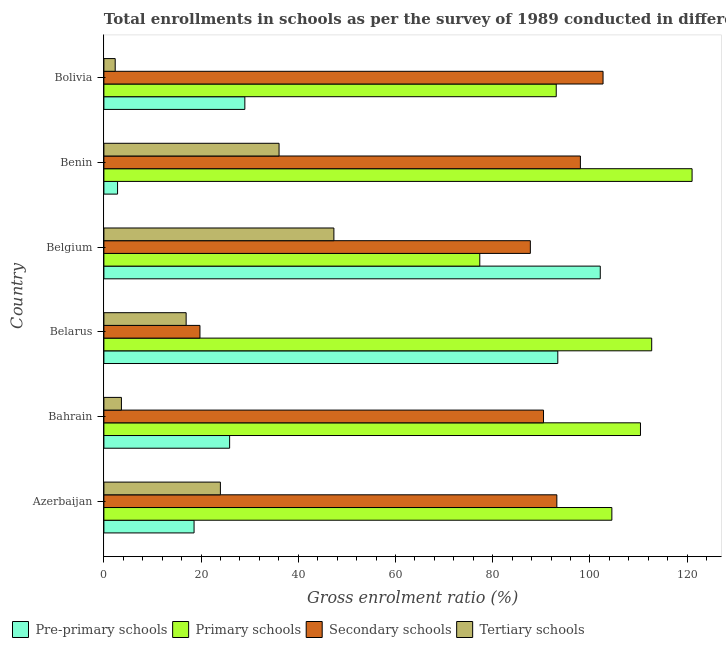How many groups of bars are there?
Your answer should be compact. 6. How many bars are there on the 6th tick from the top?
Your answer should be compact. 4. How many bars are there on the 3rd tick from the bottom?
Offer a terse response. 4. What is the label of the 4th group of bars from the top?
Provide a succinct answer. Belarus. What is the gross enrolment ratio in secondary schools in Bolivia?
Offer a very short reply. 102.7. Across all countries, what is the maximum gross enrolment ratio in pre-primary schools?
Offer a terse response. 102.13. Across all countries, what is the minimum gross enrolment ratio in tertiary schools?
Offer a very short reply. 2.33. In which country was the gross enrolment ratio in primary schools maximum?
Ensure brevity in your answer.  Benin. In which country was the gross enrolment ratio in pre-primary schools minimum?
Provide a succinct answer. Benin. What is the total gross enrolment ratio in secondary schools in the graph?
Provide a short and direct response. 491.91. What is the difference between the gross enrolment ratio in pre-primary schools in Belgium and that in Bolivia?
Offer a very short reply. 73.13. What is the difference between the gross enrolment ratio in pre-primary schools in Azerbaijan and the gross enrolment ratio in tertiary schools in Bolivia?
Provide a succinct answer. 16.22. What is the average gross enrolment ratio in tertiary schools per country?
Provide a succinct answer. 21.7. What is the difference between the gross enrolment ratio in primary schools and gross enrolment ratio in tertiary schools in Belgium?
Offer a terse response. 30.02. What is the ratio of the gross enrolment ratio in tertiary schools in Bahrain to that in Belarus?
Keep it short and to the point. 0.21. Is the gross enrolment ratio in tertiary schools in Bahrain less than that in Bolivia?
Provide a short and direct response. No. What is the difference between the highest and the second highest gross enrolment ratio in secondary schools?
Your response must be concise. 4.66. What is the difference between the highest and the lowest gross enrolment ratio in primary schools?
Give a very brief answer. 43.68. In how many countries, is the gross enrolment ratio in primary schools greater than the average gross enrolment ratio in primary schools taken over all countries?
Offer a very short reply. 4. Is the sum of the gross enrolment ratio in pre-primary schools in Belarus and Bolivia greater than the maximum gross enrolment ratio in primary schools across all countries?
Make the answer very short. Yes. Is it the case that in every country, the sum of the gross enrolment ratio in pre-primary schools and gross enrolment ratio in secondary schools is greater than the sum of gross enrolment ratio in tertiary schools and gross enrolment ratio in primary schools?
Keep it short and to the point. No. What does the 2nd bar from the top in Bolivia represents?
Offer a very short reply. Secondary schools. What does the 4th bar from the bottom in Bahrain represents?
Your answer should be compact. Tertiary schools. Is it the case that in every country, the sum of the gross enrolment ratio in pre-primary schools and gross enrolment ratio in primary schools is greater than the gross enrolment ratio in secondary schools?
Offer a very short reply. Yes. How many bars are there?
Ensure brevity in your answer.  24. How many countries are there in the graph?
Offer a very short reply. 6. Are the values on the major ticks of X-axis written in scientific E-notation?
Your response must be concise. No. Does the graph contain any zero values?
Make the answer very short. No. Does the graph contain grids?
Make the answer very short. No. How are the legend labels stacked?
Ensure brevity in your answer.  Horizontal. What is the title of the graph?
Keep it short and to the point. Total enrollments in schools as per the survey of 1989 conducted in different countries. What is the Gross enrolment ratio (%) of Pre-primary schools in Azerbaijan?
Provide a succinct answer. 18.55. What is the Gross enrolment ratio (%) of Primary schools in Azerbaijan?
Ensure brevity in your answer.  104.52. What is the Gross enrolment ratio (%) of Secondary schools in Azerbaijan?
Provide a short and direct response. 93.2. What is the Gross enrolment ratio (%) of Tertiary schools in Azerbaijan?
Your answer should be compact. 23.97. What is the Gross enrolment ratio (%) of Pre-primary schools in Bahrain?
Your response must be concise. 25.87. What is the Gross enrolment ratio (%) of Primary schools in Bahrain?
Ensure brevity in your answer.  110.4. What is the Gross enrolment ratio (%) of Secondary schools in Bahrain?
Provide a short and direct response. 90.46. What is the Gross enrolment ratio (%) in Tertiary schools in Bahrain?
Your answer should be compact. 3.61. What is the Gross enrolment ratio (%) in Pre-primary schools in Belarus?
Keep it short and to the point. 93.39. What is the Gross enrolment ratio (%) of Primary schools in Belarus?
Offer a very short reply. 112.71. What is the Gross enrolment ratio (%) of Secondary schools in Belarus?
Keep it short and to the point. 19.76. What is the Gross enrolment ratio (%) in Tertiary schools in Belarus?
Give a very brief answer. 16.92. What is the Gross enrolment ratio (%) of Pre-primary schools in Belgium?
Keep it short and to the point. 102.13. What is the Gross enrolment ratio (%) of Primary schools in Belgium?
Provide a short and direct response. 77.34. What is the Gross enrolment ratio (%) in Secondary schools in Belgium?
Offer a terse response. 87.74. What is the Gross enrolment ratio (%) in Tertiary schools in Belgium?
Offer a terse response. 47.32. What is the Gross enrolment ratio (%) of Pre-primary schools in Benin?
Offer a terse response. 2.81. What is the Gross enrolment ratio (%) in Primary schools in Benin?
Provide a short and direct response. 121.02. What is the Gross enrolment ratio (%) of Secondary schools in Benin?
Give a very brief answer. 98.04. What is the Gross enrolment ratio (%) in Tertiary schools in Benin?
Your response must be concise. 36.04. What is the Gross enrolment ratio (%) in Pre-primary schools in Bolivia?
Your answer should be very brief. 29. What is the Gross enrolment ratio (%) in Primary schools in Bolivia?
Your response must be concise. 93.07. What is the Gross enrolment ratio (%) of Secondary schools in Bolivia?
Make the answer very short. 102.7. What is the Gross enrolment ratio (%) in Tertiary schools in Bolivia?
Provide a succinct answer. 2.33. Across all countries, what is the maximum Gross enrolment ratio (%) in Pre-primary schools?
Offer a very short reply. 102.13. Across all countries, what is the maximum Gross enrolment ratio (%) in Primary schools?
Your answer should be compact. 121.02. Across all countries, what is the maximum Gross enrolment ratio (%) of Secondary schools?
Ensure brevity in your answer.  102.7. Across all countries, what is the maximum Gross enrolment ratio (%) of Tertiary schools?
Your answer should be compact. 47.32. Across all countries, what is the minimum Gross enrolment ratio (%) of Pre-primary schools?
Provide a short and direct response. 2.81. Across all countries, what is the minimum Gross enrolment ratio (%) of Primary schools?
Offer a very short reply. 77.34. Across all countries, what is the minimum Gross enrolment ratio (%) of Secondary schools?
Give a very brief answer. 19.76. Across all countries, what is the minimum Gross enrolment ratio (%) in Tertiary schools?
Ensure brevity in your answer.  2.33. What is the total Gross enrolment ratio (%) of Pre-primary schools in the graph?
Make the answer very short. 271.76. What is the total Gross enrolment ratio (%) in Primary schools in the graph?
Your answer should be compact. 619.07. What is the total Gross enrolment ratio (%) of Secondary schools in the graph?
Provide a short and direct response. 491.91. What is the total Gross enrolment ratio (%) in Tertiary schools in the graph?
Offer a terse response. 130.19. What is the difference between the Gross enrolment ratio (%) of Pre-primary schools in Azerbaijan and that in Bahrain?
Provide a short and direct response. -7.32. What is the difference between the Gross enrolment ratio (%) in Primary schools in Azerbaijan and that in Bahrain?
Offer a terse response. -5.89. What is the difference between the Gross enrolment ratio (%) in Secondary schools in Azerbaijan and that in Bahrain?
Keep it short and to the point. 2.74. What is the difference between the Gross enrolment ratio (%) of Tertiary schools in Azerbaijan and that in Bahrain?
Keep it short and to the point. 20.37. What is the difference between the Gross enrolment ratio (%) in Pre-primary schools in Azerbaijan and that in Belarus?
Make the answer very short. -74.84. What is the difference between the Gross enrolment ratio (%) of Primary schools in Azerbaijan and that in Belarus?
Your answer should be compact. -8.2. What is the difference between the Gross enrolment ratio (%) of Secondary schools in Azerbaijan and that in Belarus?
Offer a very short reply. 73.43. What is the difference between the Gross enrolment ratio (%) in Tertiary schools in Azerbaijan and that in Belarus?
Provide a succinct answer. 7.05. What is the difference between the Gross enrolment ratio (%) in Pre-primary schools in Azerbaijan and that in Belgium?
Your response must be concise. -83.58. What is the difference between the Gross enrolment ratio (%) in Primary schools in Azerbaijan and that in Belgium?
Provide a short and direct response. 27.18. What is the difference between the Gross enrolment ratio (%) in Secondary schools in Azerbaijan and that in Belgium?
Keep it short and to the point. 5.45. What is the difference between the Gross enrolment ratio (%) in Tertiary schools in Azerbaijan and that in Belgium?
Give a very brief answer. -23.35. What is the difference between the Gross enrolment ratio (%) of Pre-primary schools in Azerbaijan and that in Benin?
Make the answer very short. 15.74. What is the difference between the Gross enrolment ratio (%) in Primary schools in Azerbaijan and that in Benin?
Your answer should be compact. -16.51. What is the difference between the Gross enrolment ratio (%) of Secondary schools in Azerbaijan and that in Benin?
Give a very brief answer. -4.84. What is the difference between the Gross enrolment ratio (%) of Tertiary schools in Azerbaijan and that in Benin?
Your answer should be compact. -12.07. What is the difference between the Gross enrolment ratio (%) of Pre-primary schools in Azerbaijan and that in Bolivia?
Your answer should be very brief. -10.45. What is the difference between the Gross enrolment ratio (%) of Primary schools in Azerbaijan and that in Bolivia?
Offer a very short reply. 11.45. What is the difference between the Gross enrolment ratio (%) in Secondary schools in Azerbaijan and that in Bolivia?
Keep it short and to the point. -9.51. What is the difference between the Gross enrolment ratio (%) of Tertiary schools in Azerbaijan and that in Bolivia?
Give a very brief answer. 21.64. What is the difference between the Gross enrolment ratio (%) in Pre-primary schools in Bahrain and that in Belarus?
Your answer should be very brief. -67.52. What is the difference between the Gross enrolment ratio (%) of Primary schools in Bahrain and that in Belarus?
Ensure brevity in your answer.  -2.31. What is the difference between the Gross enrolment ratio (%) of Secondary schools in Bahrain and that in Belarus?
Provide a succinct answer. 70.69. What is the difference between the Gross enrolment ratio (%) in Tertiary schools in Bahrain and that in Belarus?
Ensure brevity in your answer.  -13.32. What is the difference between the Gross enrolment ratio (%) of Pre-primary schools in Bahrain and that in Belgium?
Provide a short and direct response. -76.26. What is the difference between the Gross enrolment ratio (%) of Primary schools in Bahrain and that in Belgium?
Keep it short and to the point. 33.06. What is the difference between the Gross enrolment ratio (%) in Secondary schools in Bahrain and that in Belgium?
Your answer should be compact. 2.71. What is the difference between the Gross enrolment ratio (%) of Tertiary schools in Bahrain and that in Belgium?
Your answer should be compact. -43.72. What is the difference between the Gross enrolment ratio (%) of Pre-primary schools in Bahrain and that in Benin?
Make the answer very short. 23.06. What is the difference between the Gross enrolment ratio (%) in Primary schools in Bahrain and that in Benin?
Keep it short and to the point. -10.62. What is the difference between the Gross enrolment ratio (%) in Secondary schools in Bahrain and that in Benin?
Ensure brevity in your answer.  -7.58. What is the difference between the Gross enrolment ratio (%) of Tertiary schools in Bahrain and that in Benin?
Offer a terse response. -32.44. What is the difference between the Gross enrolment ratio (%) in Pre-primary schools in Bahrain and that in Bolivia?
Your response must be concise. -3.13. What is the difference between the Gross enrolment ratio (%) in Primary schools in Bahrain and that in Bolivia?
Offer a terse response. 17.33. What is the difference between the Gross enrolment ratio (%) in Secondary schools in Bahrain and that in Bolivia?
Your answer should be very brief. -12.25. What is the difference between the Gross enrolment ratio (%) in Tertiary schools in Bahrain and that in Bolivia?
Make the answer very short. 1.28. What is the difference between the Gross enrolment ratio (%) in Pre-primary schools in Belarus and that in Belgium?
Keep it short and to the point. -8.74. What is the difference between the Gross enrolment ratio (%) in Primary schools in Belarus and that in Belgium?
Give a very brief answer. 35.37. What is the difference between the Gross enrolment ratio (%) in Secondary schools in Belarus and that in Belgium?
Give a very brief answer. -67.98. What is the difference between the Gross enrolment ratio (%) in Tertiary schools in Belarus and that in Belgium?
Your response must be concise. -30.4. What is the difference between the Gross enrolment ratio (%) of Pre-primary schools in Belarus and that in Benin?
Give a very brief answer. 90.58. What is the difference between the Gross enrolment ratio (%) of Primary schools in Belarus and that in Benin?
Offer a terse response. -8.31. What is the difference between the Gross enrolment ratio (%) in Secondary schools in Belarus and that in Benin?
Your answer should be compact. -78.28. What is the difference between the Gross enrolment ratio (%) of Tertiary schools in Belarus and that in Benin?
Your answer should be compact. -19.12. What is the difference between the Gross enrolment ratio (%) of Pre-primary schools in Belarus and that in Bolivia?
Provide a succinct answer. 64.39. What is the difference between the Gross enrolment ratio (%) of Primary schools in Belarus and that in Bolivia?
Your response must be concise. 19.64. What is the difference between the Gross enrolment ratio (%) of Secondary schools in Belarus and that in Bolivia?
Make the answer very short. -82.94. What is the difference between the Gross enrolment ratio (%) in Tertiary schools in Belarus and that in Bolivia?
Ensure brevity in your answer.  14.59. What is the difference between the Gross enrolment ratio (%) in Pre-primary schools in Belgium and that in Benin?
Your response must be concise. 99.32. What is the difference between the Gross enrolment ratio (%) of Primary schools in Belgium and that in Benin?
Offer a terse response. -43.68. What is the difference between the Gross enrolment ratio (%) of Secondary schools in Belgium and that in Benin?
Offer a terse response. -10.3. What is the difference between the Gross enrolment ratio (%) in Tertiary schools in Belgium and that in Benin?
Provide a succinct answer. 11.28. What is the difference between the Gross enrolment ratio (%) in Pre-primary schools in Belgium and that in Bolivia?
Make the answer very short. 73.13. What is the difference between the Gross enrolment ratio (%) of Primary schools in Belgium and that in Bolivia?
Make the answer very short. -15.73. What is the difference between the Gross enrolment ratio (%) of Secondary schools in Belgium and that in Bolivia?
Your answer should be very brief. -14.96. What is the difference between the Gross enrolment ratio (%) in Tertiary schools in Belgium and that in Bolivia?
Ensure brevity in your answer.  45. What is the difference between the Gross enrolment ratio (%) in Pre-primary schools in Benin and that in Bolivia?
Your answer should be compact. -26.19. What is the difference between the Gross enrolment ratio (%) of Primary schools in Benin and that in Bolivia?
Provide a short and direct response. 27.95. What is the difference between the Gross enrolment ratio (%) in Secondary schools in Benin and that in Bolivia?
Your answer should be very brief. -4.66. What is the difference between the Gross enrolment ratio (%) of Tertiary schools in Benin and that in Bolivia?
Give a very brief answer. 33.71. What is the difference between the Gross enrolment ratio (%) in Pre-primary schools in Azerbaijan and the Gross enrolment ratio (%) in Primary schools in Bahrain?
Make the answer very short. -91.85. What is the difference between the Gross enrolment ratio (%) in Pre-primary schools in Azerbaijan and the Gross enrolment ratio (%) in Secondary schools in Bahrain?
Give a very brief answer. -71.9. What is the difference between the Gross enrolment ratio (%) of Pre-primary schools in Azerbaijan and the Gross enrolment ratio (%) of Tertiary schools in Bahrain?
Your response must be concise. 14.95. What is the difference between the Gross enrolment ratio (%) in Primary schools in Azerbaijan and the Gross enrolment ratio (%) in Secondary schools in Bahrain?
Your answer should be very brief. 14.06. What is the difference between the Gross enrolment ratio (%) of Primary schools in Azerbaijan and the Gross enrolment ratio (%) of Tertiary schools in Bahrain?
Ensure brevity in your answer.  100.91. What is the difference between the Gross enrolment ratio (%) of Secondary schools in Azerbaijan and the Gross enrolment ratio (%) of Tertiary schools in Bahrain?
Your response must be concise. 89.59. What is the difference between the Gross enrolment ratio (%) of Pre-primary schools in Azerbaijan and the Gross enrolment ratio (%) of Primary schools in Belarus?
Offer a terse response. -94.16. What is the difference between the Gross enrolment ratio (%) in Pre-primary schools in Azerbaijan and the Gross enrolment ratio (%) in Secondary schools in Belarus?
Provide a short and direct response. -1.21. What is the difference between the Gross enrolment ratio (%) in Pre-primary schools in Azerbaijan and the Gross enrolment ratio (%) in Tertiary schools in Belarus?
Provide a short and direct response. 1.63. What is the difference between the Gross enrolment ratio (%) in Primary schools in Azerbaijan and the Gross enrolment ratio (%) in Secondary schools in Belarus?
Offer a very short reply. 84.75. What is the difference between the Gross enrolment ratio (%) of Primary schools in Azerbaijan and the Gross enrolment ratio (%) of Tertiary schools in Belarus?
Your answer should be compact. 87.6. What is the difference between the Gross enrolment ratio (%) in Secondary schools in Azerbaijan and the Gross enrolment ratio (%) in Tertiary schools in Belarus?
Give a very brief answer. 76.28. What is the difference between the Gross enrolment ratio (%) of Pre-primary schools in Azerbaijan and the Gross enrolment ratio (%) of Primary schools in Belgium?
Your response must be concise. -58.79. What is the difference between the Gross enrolment ratio (%) of Pre-primary schools in Azerbaijan and the Gross enrolment ratio (%) of Secondary schools in Belgium?
Offer a terse response. -69.19. What is the difference between the Gross enrolment ratio (%) in Pre-primary schools in Azerbaijan and the Gross enrolment ratio (%) in Tertiary schools in Belgium?
Offer a very short reply. -28.77. What is the difference between the Gross enrolment ratio (%) of Primary schools in Azerbaijan and the Gross enrolment ratio (%) of Secondary schools in Belgium?
Provide a short and direct response. 16.77. What is the difference between the Gross enrolment ratio (%) of Primary schools in Azerbaijan and the Gross enrolment ratio (%) of Tertiary schools in Belgium?
Make the answer very short. 57.19. What is the difference between the Gross enrolment ratio (%) of Secondary schools in Azerbaijan and the Gross enrolment ratio (%) of Tertiary schools in Belgium?
Your answer should be very brief. 45.87. What is the difference between the Gross enrolment ratio (%) in Pre-primary schools in Azerbaijan and the Gross enrolment ratio (%) in Primary schools in Benin?
Offer a terse response. -102.47. What is the difference between the Gross enrolment ratio (%) of Pre-primary schools in Azerbaijan and the Gross enrolment ratio (%) of Secondary schools in Benin?
Offer a terse response. -79.49. What is the difference between the Gross enrolment ratio (%) in Pre-primary schools in Azerbaijan and the Gross enrolment ratio (%) in Tertiary schools in Benin?
Keep it short and to the point. -17.49. What is the difference between the Gross enrolment ratio (%) of Primary schools in Azerbaijan and the Gross enrolment ratio (%) of Secondary schools in Benin?
Your answer should be very brief. 6.48. What is the difference between the Gross enrolment ratio (%) in Primary schools in Azerbaijan and the Gross enrolment ratio (%) in Tertiary schools in Benin?
Keep it short and to the point. 68.48. What is the difference between the Gross enrolment ratio (%) of Secondary schools in Azerbaijan and the Gross enrolment ratio (%) of Tertiary schools in Benin?
Provide a short and direct response. 57.16. What is the difference between the Gross enrolment ratio (%) in Pre-primary schools in Azerbaijan and the Gross enrolment ratio (%) in Primary schools in Bolivia?
Your answer should be compact. -74.52. What is the difference between the Gross enrolment ratio (%) of Pre-primary schools in Azerbaijan and the Gross enrolment ratio (%) of Secondary schools in Bolivia?
Offer a terse response. -84.15. What is the difference between the Gross enrolment ratio (%) in Pre-primary schools in Azerbaijan and the Gross enrolment ratio (%) in Tertiary schools in Bolivia?
Your answer should be compact. 16.22. What is the difference between the Gross enrolment ratio (%) of Primary schools in Azerbaijan and the Gross enrolment ratio (%) of Secondary schools in Bolivia?
Offer a very short reply. 1.81. What is the difference between the Gross enrolment ratio (%) in Primary schools in Azerbaijan and the Gross enrolment ratio (%) in Tertiary schools in Bolivia?
Give a very brief answer. 102.19. What is the difference between the Gross enrolment ratio (%) of Secondary schools in Azerbaijan and the Gross enrolment ratio (%) of Tertiary schools in Bolivia?
Ensure brevity in your answer.  90.87. What is the difference between the Gross enrolment ratio (%) in Pre-primary schools in Bahrain and the Gross enrolment ratio (%) in Primary schools in Belarus?
Your answer should be very brief. -86.84. What is the difference between the Gross enrolment ratio (%) in Pre-primary schools in Bahrain and the Gross enrolment ratio (%) in Secondary schools in Belarus?
Give a very brief answer. 6.11. What is the difference between the Gross enrolment ratio (%) in Pre-primary schools in Bahrain and the Gross enrolment ratio (%) in Tertiary schools in Belarus?
Give a very brief answer. 8.95. What is the difference between the Gross enrolment ratio (%) in Primary schools in Bahrain and the Gross enrolment ratio (%) in Secondary schools in Belarus?
Make the answer very short. 90.64. What is the difference between the Gross enrolment ratio (%) of Primary schools in Bahrain and the Gross enrolment ratio (%) of Tertiary schools in Belarus?
Give a very brief answer. 93.48. What is the difference between the Gross enrolment ratio (%) of Secondary schools in Bahrain and the Gross enrolment ratio (%) of Tertiary schools in Belarus?
Provide a short and direct response. 73.53. What is the difference between the Gross enrolment ratio (%) of Pre-primary schools in Bahrain and the Gross enrolment ratio (%) of Primary schools in Belgium?
Your answer should be very brief. -51.47. What is the difference between the Gross enrolment ratio (%) in Pre-primary schools in Bahrain and the Gross enrolment ratio (%) in Secondary schools in Belgium?
Offer a very short reply. -61.87. What is the difference between the Gross enrolment ratio (%) of Pre-primary schools in Bahrain and the Gross enrolment ratio (%) of Tertiary schools in Belgium?
Provide a succinct answer. -21.45. What is the difference between the Gross enrolment ratio (%) of Primary schools in Bahrain and the Gross enrolment ratio (%) of Secondary schools in Belgium?
Keep it short and to the point. 22.66. What is the difference between the Gross enrolment ratio (%) of Primary schools in Bahrain and the Gross enrolment ratio (%) of Tertiary schools in Belgium?
Offer a terse response. 63.08. What is the difference between the Gross enrolment ratio (%) of Secondary schools in Bahrain and the Gross enrolment ratio (%) of Tertiary schools in Belgium?
Your response must be concise. 43.13. What is the difference between the Gross enrolment ratio (%) in Pre-primary schools in Bahrain and the Gross enrolment ratio (%) in Primary schools in Benin?
Provide a succinct answer. -95.15. What is the difference between the Gross enrolment ratio (%) of Pre-primary schools in Bahrain and the Gross enrolment ratio (%) of Secondary schools in Benin?
Provide a short and direct response. -72.17. What is the difference between the Gross enrolment ratio (%) of Pre-primary schools in Bahrain and the Gross enrolment ratio (%) of Tertiary schools in Benin?
Ensure brevity in your answer.  -10.17. What is the difference between the Gross enrolment ratio (%) in Primary schools in Bahrain and the Gross enrolment ratio (%) in Secondary schools in Benin?
Your answer should be compact. 12.36. What is the difference between the Gross enrolment ratio (%) of Primary schools in Bahrain and the Gross enrolment ratio (%) of Tertiary schools in Benin?
Provide a short and direct response. 74.36. What is the difference between the Gross enrolment ratio (%) of Secondary schools in Bahrain and the Gross enrolment ratio (%) of Tertiary schools in Benin?
Your response must be concise. 54.41. What is the difference between the Gross enrolment ratio (%) of Pre-primary schools in Bahrain and the Gross enrolment ratio (%) of Primary schools in Bolivia?
Offer a very short reply. -67.2. What is the difference between the Gross enrolment ratio (%) in Pre-primary schools in Bahrain and the Gross enrolment ratio (%) in Secondary schools in Bolivia?
Offer a terse response. -76.83. What is the difference between the Gross enrolment ratio (%) of Pre-primary schools in Bahrain and the Gross enrolment ratio (%) of Tertiary schools in Bolivia?
Provide a short and direct response. 23.54. What is the difference between the Gross enrolment ratio (%) of Primary schools in Bahrain and the Gross enrolment ratio (%) of Secondary schools in Bolivia?
Offer a very short reply. 7.7. What is the difference between the Gross enrolment ratio (%) of Primary schools in Bahrain and the Gross enrolment ratio (%) of Tertiary schools in Bolivia?
Make the answer very short. 108.07. What is the difference between the Gross enrolment ratio (%) of Secondary schools in Bahrain and the Gross enrolment ratio (%) of Tertiary schools in Bolivia?
Offer a terse response. 88.13. What is the difference between the Gross enrolment ratio (%) in Pre-primary schools in Belarus and the Gross enrolment ratio (%) in Primary schools in Belgium?
Your answer should be very brief. 16.05. What is the difference between the Gross enrolment ratio (%) of Pre-primary schools in Belarus and the Gross enrolment ratio (%) of Secondary schools in Belgium?
Offer a terse response. 5.65. What is the difference between the Gross enrolment ratio (%) of Pre-primary schools in Belarus and the Gross enrolment ratio (%) of Tertiary schools in Belgium?
Give a very brief answer. 46.07. What is the difference between the Gross enrolment ratio (%) in Primary schools in Belarus and the Gross enrolment ratio (%) in Secondary schools in Belgium?
Offer a terse response. 24.97. What is the difference between the Gross enrolment ratio (%) in Primary schools in Belarus and the Gross enrolment ratio (%) in Tertiary schools in Belgium?
Offer a terse response. 65.39. What is the difference between the Gross enrolment ratio (%) of Secondary schools in Belarus and the Gross enrolment ratio (%) of Tertiary schools in Belgium?
Give a very brief answer. -27.56. What is the difference between the Gross enrolment ratio (%) in Pre-primary schools in Belarus and the Gross enrolment ratio (%) in Primary schools in Benin?
Keep it short and to the point. -27.63. What is the difference between the Gross enrolment ratio (%) of Pre-primary schools in Belarus and the Gross enrolment ratio (%) of Secondary schools in Benin?
Provide a short and direct response. -4.65. What is the difference between the Gross enrolment ratio (%) of Pre-primary schools in Belarus and the Gross enrolment ratio (%) of Tertiary schools in Benin?
Your response must be concise. 57.35. What is the difference between the Gross enrolment ratio (%) in Primary schools in Belarus and the Gross enrolment ratio (%) in Secondary schools in Benin?
Provide a succinct answer. 14.67. What is the difference between the Gross enrolment ratio (%) in Primary schools in Belarus and the Gross enrolment ratio (%) in Tertiary schools in Benin?
Provide a short and direct response. 76.67. What is the difference between the Gross enrolment ratio (%) in Secondary schools in Belarus and the Gross enrolment ratio (%) in Tertiary schools in Benin?
Keep it short and to the point. -16.28. What is the difference between the Gross enrolment ratio (%) in Pre-primary schools in Belarus and the Gross enrolment ratio (%) in Primary schools in Bolivia?
Ensure brevity in your answer.  0.32. What is the difference between the Gross enrolment ratio (%) of Pre-primary schools in Belarus and the Gross enrolment ratio (%) of Secondary schools in Bolivia?
Your answer should be compact. -9.31. What is the difference between the Gross enrolment ratio (%) in Pre-primary schools in Belarus and the Gross enrolment ratio (%) in Tertiary schools in Bolivia?
Your response must be concise. 91.07. What is the difference between the Gross enrolment ratio (%) in Primary schools in Belarus and the Gross enrolment ratio (%) in Secondary schools in Bolivia?
Provide a succinct answer. 10.01. What is the difference between the Gross enrolment ratio (%) in Primary schools in Belarus and the Gross enrolment ratio (%) in Tertiary schools in Bolivia?
Make the answer very short. 110.39. What is the difference between the Gross enrolment ratio (%) in Secondary schools in Belarus and the Gross enrolment ratio (%) in Tertiary schools in Bolivia?
Make the answer very short. 17.44. What is the difference between the Gross enrolment ratio (%) in Pre-primary schools in Belgium and the Gross enrolment ratio (%) in Primary schools in Benin?
Offer a terse response. -18.89. What is the difference between the Gross enrolment ratio (%) in Pre-primary schools in Belgium and the Gross enrolment ratio (%) in Secondary schools in Benin?
Your response must be concise. 4.09. What is the difference between the Gross enrolment ratio (%) of Pre-primary schools in Belgium and the Gross enrolment ratio (%) of Tertiary schools in Benin?
Your response must be concise. 66.09. What is the difference between the Gross enrolment ratio (%) in Primary schools in Belgium and the Gross enrolment ratio (%) in Secondary schools in Benin?
Offer a very short reply. -20.7. What is the difference between the Gross enrolment ratio (%) of Primary schools in Belgium and the Gross enrolment ratio (%) of Tertiary schools in Benin?
Your answer should be compact. 41.3. What is the difference between the Gross enrolment ratio (%) in Secondary schools in Belgium and the Gross enrolment ratio (%) in Tertiary schools in Benin?
Give a very brief answer. 51.7. What is the difference between the Gross enrolment ratio (%) of Pre-primary schools in Belgium and the Gross enrolment ratio (%) of Primary schools in Bolivia?
Provide a short and direct response. 9.06. What is the difference between the Gross enrolment ratio (%) of Pre-primary schools in Belgium and the Gross enrolment ratio (%) of Secondary schools in Bolivia?
Your response must be concise. -0.57. What is the difference between the Gross enrolment ratio (%) in Pre-primary schools in Belgium and the Gross enrolment ratio (%) in Tertiary schools in Bolivia?
Provide a succinct answer. 99.8. What is the difference between the Gross enrolment ratio (%) in Primary schools in Belgium and the Gross enrolment ratio (%) in Secondary schools in Bolivia?
Provide a short and direct response. -25.36. What is the difference between the Gross enrolment ratio (%) of Primary schools in Belgium and the Gross enrolment ratio (%) of Tertiary schools in Bolivia?
Your answer should be very brief. 75.01. What is the difference between the Gross enrolment ratio (%) in Secondary schools in Belgium and the Gross enrolment ratio (%) in Tertiary schools in Bolivia?
Your answer should be compact. 85.42. What is the difference between the Gross enrolment ratio (%) of Pre-primary schools in Benin and the Gross enrolment ratio (%) of Primary schools in Bolivia?
Provide a succinct answer. -90.26. What is the difference between the Gross enrolment ratio (%) of Pre-primary schools in Benin and the Gross enrolment ratio (%) of Secondary schools in Bolivia?
Offer a very short reply. -99.89. What is the difference between the Gross enrolment ratio (%) of Pre-primary schools in Benin and the Gross enrolment ratio (%) of Tertiary schools in Bolivia?
Keep it short and to the point. 0.48. What is the difference between the Gross enrolment ratio (%) of Primary schools in Benin and the Gross enrolment ratio (%) of Secondary schools in Bolivia?
Make the answer very short. 18.32. What is the difference between the Gross enrolment ratio (%) of Primary schools in Benin and the Gross enrolment ratio (%) of Tertiary schools in Bolivia?
Your response must be concise. 118.69. What is the difference between the Gross enrolment ratio (%) of Secondary schools in Benin and the Gross enrolment ratio (%) of Tertiary schools in Bolivia?
Keep it short and to the point. 95.71. What is the average Gross enrolment ratio (%) of Pre-primary schools per country?
Make the answer very short. 45.29. What is the average Gross enrolment ratio (%) of Primary schools per country?
Ensure brevity in your answer.  103.18. What is the average Gross enrolment ratio (%) of Secondary schools per country?
Give a very brief answer. 81.98. What is the average Gross enrolment ratio (%) of Tertiary schools per country?
Make the answer very short. 21.7. What is the difference between the Gross enrolment ratio (%) in Pre-primary schools and Gross enrolment ratio (%) in Primary schools in Azerbaijan?
Your answer should be compact. -85.97. What is the difference between the Gross enrolment ratio (%) in Pre-primary schools and Gross enrolment ratio (%) in Secondary schools in Azerbaijan?
Your response must be concise. -74.65. What is the difference between the Gross enrolment ratio (%) in Pre-primary schools and Gross enrolment ratio (%) in Tertiary schools in Azerbaijan?
Offer a terse response. -5.42. What is the difference between the Gross enrolment ratio (%) in Primary schools and Gross enrolment ratio (%) in Secondary schools in Azerbaijan?
Your response must be concise. 11.32. What is the difference between the Gross enrolment ratio (%) in Primary schools and Gross enrolment ratio (%) in Tertiary schools in Azerbaijan?
Give a very brief answer. 80.55. What is the difference between the Gross enrolment ratio (%) of Secondary schools and Gross enrolment ratio (%) of Tertiary schools in Azerbaijan?
Offer a very short reply. 69.23. What is the difference between the Gross enrolment ratio (%) of Pre-primary schools and Gross enrolment ratio (%) of Primary schools in Bahrain?
Your answer should be very brief. -84.53. What is the difference between the Gross enrolment ratio (%) in Pre-primary schools and Gross enrolment ratio (%) in Secondary schools in Bahrain?
Your response must be concise. -64.58. What is the difference between the Gross enrolment ratio (%) in Pre-primary schools and Gross enrolment ratio (%) in Tertiary schools in Bahrain?
Keep it short and to the point. 22.26. What is the difference between the Gross enrolment ratio (%) of Primary schools and Gross enrolment ratio (%) of Secondary schools in Bahrain?
Your response must be concise. 19.95. What is the difference between the Gross enrolment ratio (%) of Primary schools and Gross enrolment ratio (%) of Tertiary schools in Bahrain?
Your answer should be very brief. 106.8. What is the difference between the Gross enrolment ratio (%) of Secondary schools and Gross enrolment ratio (%) of Tertiary schools in Bahrain?
Offer a terse response. 86.85. What is the difference between the Gross enrolment ratio (%) in Pre-primary schools and Gross enrolment ratio (%) in Primary schools in Belarus?
Make the answer very short. -19.32. What is the difference between the Gross enrolment ratio (%) of Pre-primary schools and Gross enrolment ratio (%) of Secondary schools in Belarus?
Keep it short and to the point. 73.63. What is the difference between the Gross enrolment ratio (%) of Pre-primary schools and Gross enrolment ratio (%) of Tertiary schools in Belarus?
Your response must be concise. 76.47. What is the difference between the Gross enrolment ratio (%) in Primary schools and Gross enrolment ratio (%) in Secondary schools in Belarus?
Ensure brevity in your answer.  92.95. What is the difference between the Gross enrolment ratio (%) of Primary schools and Gross enrolment ratio (%) of Tertiary schools in Belarus?
Your answer should be very brief. 95.79. What is the difference between the Gross enrolment ratio (%) in Secondary schools and Gross enrolment ratio (%) in Tertiary schools in Belarus?
Give a very brief answer. 2.84. What is the difference between the Gross enrolment ratio (%) in Pre-primary schools and Gross enrolment ratio (%) in Primary schools in Belgium?
Your answer should be very brief. 24.79. What is the difference between the Gross enrolment ratio (%) in Pre-primary schools and Gross enrolment ratio (%) in Secondary schools in Belgium?
Give a very brief answer. 14.39. What is the difference between the Gross enrolment ratio (%) of Pre-primary schools and Gross enrolment ratio (%) of Tertiary schools in Belgium?
Your answer should be compact. 54.81. What is the difference between the Gross enrolment ratio (%) of Primary schools and Gross enrolment ratio (%) of Secondary schools in Belgium?
Provide a succinct answer. -10.4. What is the difference between the Gross enrolment ratio (%) of Primary schools and Gross enrolment ratio (%) of Tertiary schools in Belgium?
Keep it short and to the point. 30.02. What is the difference between the Gross enrolment ratio (%) of Secondary schools and Gross enrolment ratio (%) of Tertiary schools in Belgium?
Your answer should be very brief. 40.42. What is the difference between the Gross enrolment ratio (%) in Pre-primary schools and Gross enrolment ratio (%) in Primary schools in Benin?
Provide a succinct answer. -118.21. What is the difference between the Gross enrolment ratio (%) of Pre-primary schools and Gross enrolment ratio (%) of Secondary schools in Benin?
Your answer should be compact. -95.23. What is the difference between the Gross enrolment ratio (%) of Pre-primary schools and Gross enrolment ratio (%) of Tertiary schools in Benin?
Offer a terse response. -33.23. What is the difference between the Gross enrolment ratio (%) in Primary schools and Gross enrolment ratio (%) in Secondary schools in Benin?
Offer a very short reply. 22.98. What is the difference between the Gross enrolment ratio (%) of Primary schools and Gross enrolment ratio (%) of Tertiary schools in Benin?
Your answer should be compact. 84.98. What is the difference between the Gross enrolment ratio (%) in Secondary schools and Gross enrolment ratio (%) in Tertiary schools in Benin?
Offer a very short reply. 62. What is the difference between the Gross enrolment ratio (%) of Pre-primary schools and Gross enrolment ratio (%) of Primary schools in Bolivia?
Provide a short and direct response. -64.07. What is the difference between the Gross enrolment ratio (%) in Pre-primary schools and Gross enrolment ratio (%) in Secondary schools in Bolivia?
Your answer should be compact. -73.7. What is the difference between the Gross enrolment ratio (%) in Pre-primary schools and Gross enrolment ratio (%) in Tertiary schools in Bolivia?
Give a very brief answer. 26.67. What is the difference between the Gross enrolment ratio (%) in Primary schools and Gross enrolment ratio (%) in Secondary schools in Bolivia?
Provide a short and direct response. -9.63. What is the difference between the Gross enrolment ratio (%) of Primary schools and Gross enrolment ratio (%) of Tertiary schools in Bolivia?
Offer a very short reply. 90.74. What is the difference between the Gross enrolment ratio (%) of Secondary schools and Gross enrolment ratio (%) of Tertiary schools in Bolivia?
Provide a succinct answer. 100.38. What is the ratio of the Gross enrolment ratio (%) in Pre-primary schools in Azerbaijan to that in Bahrain?
Give a very brief answer. 0.72. What is the ratio of the Gross enrolment ratio (%) of Primary schools in Azerbaijan to that in Bahrain?
Offer a terse response. 0.95. What is the ratio of the Gross enrolment ratio (%) in Secondary schools in Azerbaijan to that in Bahrain?
Make the answer very short. 1.03. What is the ratio of the Gross enrolment ratio (%) of Tertiary schools in Azerbaijan to that in Bahrain?
Make the answer very short. 6.65. What is the ratio of the Gross enrolment ratio (%) of Pre-primary schools in Azerbaijan to that in Belarus?
Your answer should be very brief. 0.2. What is the ratio of the Gross enrolment ratio (%) of Primary schools in Azerbaijan to that in Belarus?
Your answer should be very brief. 0.93. What is the ratio of the Gross enrolment ratio (%) in Secondary schools in Azerbaijan to that in Belarus?
Your response must be concise. 4.72. What is the ratio of the Gross enrolment ratio (%) of Tertiary schools in Azerbaijan to that in Belarus?
Keep it short and to the point. 1.42. What is the ratio of the Gross enrolment ratio (%) in Pre-primary schools in Azerbaijan to that in Belgium?
Ensure brevity in your answer.  0.18. What is the ratio of the Gross enrolment ratio (%) in Primary schools in Azerbaijan to that in Belgium?
Make the answer very short. 1.35. What is the ratio of the Gross enrolment ratio (%) of Secondary schools in Azerbaijan to that in Belgium?
Your answer should be very brief. 1.06. What is the ratio of the Gross enrolment ratio (%) of Tertiary schools in Azerbaijan to that in Belgium?
Your response must be concise. 0.51. What is the ratio of the Gross enrolment ratio (%) of Pre-primary schools in Azerbaijan to that in Benin?
Offer a very short reply. 6.6. What is the ratio of the Gross enrolment ratio (%) of Primary schools in Azerbaijan to that in Benin?
Offer a terse response. 0.86. What is the ratio of the Gross enrolment ratio (%) in Secondary schools in Azerbaijan to that in Benin?
Offer a very short reply. 0.95. What is the ratio of the Gross enrolment ratio (%) of Tertiary schools in Azerbaijan to that in Benin?
Offer a terse response. 0.67. What is the ratio of the Gross enrolment ratio (%) in Pre-primary schools in Azerbaijan to that in Bolivia?
Ensure brevity in your answer.  0.64. What is the ratio of the Gross enrolment ratio (%) of Primary schools in Azerbaijan to that in Bolivia?
Provide a short and direct response. 1.12. What is the ratio of the Gross enrolment ratio (%) of Secondary schools in Azerbaijan to that in Bolivia?
Keep it short and to the point. 0.91. What is the ratio of the Gross enrolment ratio (%) in Tertiary schools in Azerbaijan to that in Bolivia?
Your answer should be very brief. 10.29. What is the ratio of the Gross enrolment ratio (%) in Pre-primary schools in Bahrain to that in Belarus?
Your answer should be very brief. 0.28. What is the ratio of the Gross enrolment ratio (%) in Primary schools in Bahrain to that in Belarus?
Ensure brevity in your answer.  0.98. What is the ratio of the Gross enrolment ratio (%) in Secondary schools in Bahrain to that in Belarus?
Your answer should be very brief. 4.58. What is the ratio of the Gross enrolment ratio (%) in Tertiary schools in Bahrain to that in Belarus?
Your answer should be compact. 0.21. What is the ratio of the Gross enrolment ratio (%) in Pre-primary schools in Bahrain to that in Belgium?
Keep it short and to the point. 0.25. What is the ratio of the Gross enrolment ratio (%) of Primary schools in Bahrain to that in Belgium?
Make the answer very short. 1.43. What is the ratio of the Gross enrolment ratio (%) of Secondary schools in Bahrain to that in Belgium?
Provide a short and direct response. 1.03. What is the ratio of the Gross enrolment ratio (%) in Tertiary schools in Bahrain to that in Belgium?
Provide a short and direct response. 0.08. What is the ratio of the Gross enrolment ratio (%) of Pre-primary schools in Bahrain to that in Benin?
Make the answer very short. 9.2. What is the ratio of the Gross enrolment ratio (%) in Primary schools in Bahrain to that in Benin?
Keep it short and to the point. 0.91. What is the ratio of the Gross enrolment ratio (%) in Secondary schools in Bahrain to that in Benin?
Your response must be concise. 0.92. What is the ratio of the Gross enrolment ratio (%) of Tertiary schools in Bahrain to that in Benin?
Your response must be concise. 0.1. What is the ratio of the Gross enrolment ratio (%) in Pre-primary schools in Bahrain to that in Bolivia?
Keep it short and to the point. 0.89. What is the ratio of the Gross enrolment ratio (%) in Primary schools in Bahrain to that in Bolivia?
Keep it short and to the point. 1.19. What is the ratio of the Gross enrolment ratio (%) in Secondary schools in Bahrain to that in Bolivia?
Offer a very short reply. 0.88. What is the ratio of the Gross enrolment ratio (%) in Tertiary schools in Bahrain to that in Bolivia?
Give a very brief answer. 1.55. What is the ratio of the Gross enrolment ratio (%) of Pre-primary schools in Belarus to that in Belgium?
Keep it short and to the point. 0.91. What is the ratio of the Gross enrolment ratio (%) in Primary schools in Belarus to that in Belgium?
Give a very brief answer. 1.46. What is the ratio of the Gross enrolment ratio (%) of Secondary schools in Belarus to that in Belgium?
Your answer should be very brief. 0.23. What is the ratio of the Gross enrolment ratio (%) in Tertiary schools in Belarus to that in Belgium?
Ensure brevity in your answer.  0.36. What is the ratio of the Gross enrolment ratio (%) in Pre-primary schools in Belarus to that in Benin?
Your response must be concise. 33.21. What is the ratio of the Gross enrolment ratio (%) in Primary schools in Belarus to that in Benin?
Offer a very short reply. 0.93. What is the ratio of the Gross enrolment ratio (%) of Secondary schools in Belarus to that in Benin?
Provide a short and direct response. 0.2. What is the ratio of the Gross enrolment ratio (%) of Tertiary schools in Belarus to that in Benin?
Keep it short and to the point. 0.47. What is the ratio of the Gross enrolment ratio (%) of Pre-primary schools in Belarus to that in Bolivia?
Make the answer very short. 3.22. What is the ratio of the Gross enrolment ratio (%) in Primary schools in Belarus to that in Bolivia?
Your answer should be compact. 1.21. What is the ratio of the Gross enrolment ratio (%) of Secondary schools in Belarus to that in Bolivia?
Make the answer very short. 0.19. What is the ratio of the Gross enrolment ratio (%) of Tertiary schools in Belarus to that in Bolivia?
Your answer should be very brief. 7.27. What is the ratio of the Gross enrolment ratio (%) in Pre-primary schools in Belgium to that in Benin?
Provide a succinct answer. 36.31. What is the ratio of the Gross enrolment ratio (%) of Primary schools in Belgium to that in Benin?
Offer a terse response. 0.64. What is the ratio of the Gross enrolment ratio (%) in Secondary schools in Belgium to that in Benin?
Keep it short and to the point. 0.9. What is the ratio of the Gross enrolment ratio (%) in Tertiary schools in Belgium to that in Benin?
Ensure brevity in your answer.  1.31. What is the ratio of the Gross enrolment ratio (%) of Pre-primary schools in Belgium to that in Bolivia?
Offer a terse response. 3.52. What is the ratio of the Gross enrolment ratio (%) in Primary schools in Belgium to that in Bolivia?
Provide a short and direct response. 0.83. What is the ratio of the Gross enrolment ratio (%) of Secondary schools in Belgium to that in Bolivia?
Your response must be concise. 0.85. What is the ratio of the Gross enrolment ratio (%) in Tertiary schools in Belgium to that in Bolivia?
Your answer should be compact. 20.32. What is the ratio of the Gross enrolment ratio (%) in Pre-primary schools in Benin to that in Bolivia?
Your response must be concise. 0.1. What is the ratio of the Gross enrolment ratio (%) of Primary schools in Benin to that in Bolivia?
Your response must be concise. 1.3. What is the ratio of the Gross enrolment ratio (%) in Secondary schools in Benin to that in Bolivia?
Give a very brief answer. 0.95. What is the ratio of the Gross enrolment ratio (%) of Tertiary schools in Benin to that in Bolivia?
Your answer should be very brief. 15.48. What is the difference between the highest and the second highest Gross enrolment ratio (%) of Pre-primary schools?
Your answer should be very brief. 8.74. What is the difference between the highest and the second highest Gross enrolment ratio (%) of Primary schools?
Offer a terse response. 8.31. What is the difference between the highest and the second highest Gross enrolment ratio (%) of Secondary schools?
Your answer should be compact. 4.66. What is the difference between the highest and the second highest Gross enrolment ratio (%) in Tertiary schools?
Give a very brief answer. 11.28. What is the difference between the highest and the lowest Gross enrolment ratio (%) in Pre-primary schools?
Make the answer very short. 99.32. What is the difference between the highest and the lowest Gross enrolment ratio (%) of Primary schools?
Provide a succinct answer. 43.68. What is the difference between the highest and the lowest Gross enrolment ratio (%) of Secondary schools?
Your answer should be compact. 82.94. What is the difference between the highest and the lowest Gross enrolment ratio (%) of Tertiary schools?
Provide a succinct answer. 45. 